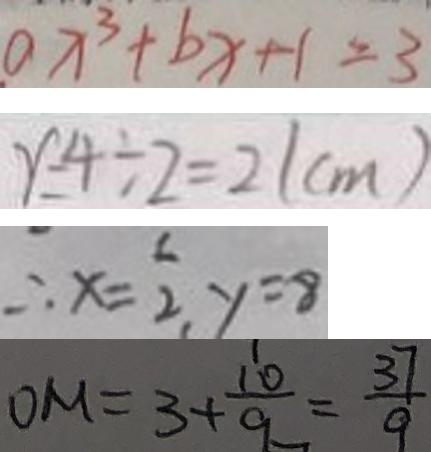<formula> <loc_0><loc_0><loc_500><loc_500>a x ^ { 3 } + b x + 1 = 3 
 r = 4 \div 2 = 2 ( c m ) 
 \therefore x = \frac { 1 } { 2 } , y = 8 
 O M = 3 + \frac { 1 0 } { 9 } = \frac { 3 7 } { 9 }</formula> 